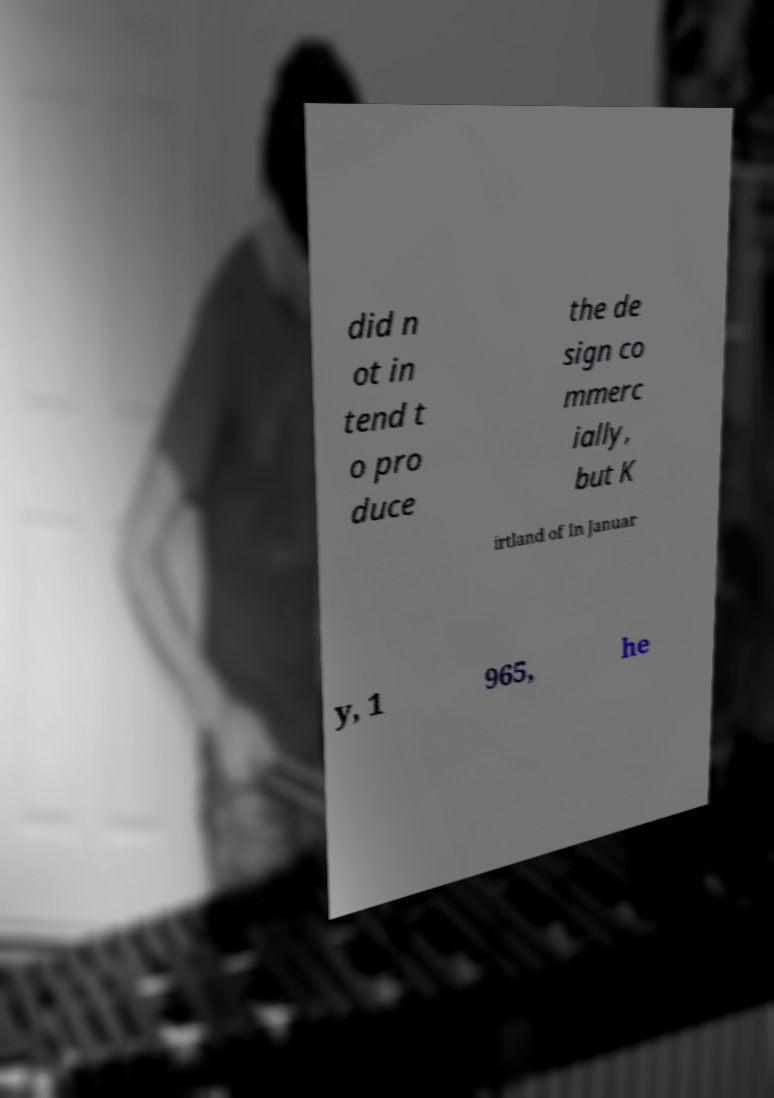Can you accurately transcribe the text from the provided image for me? did n ot in tend t o pro duce the de sign co mmerc ially, but K irtland of In Januar y, 1 965, he 